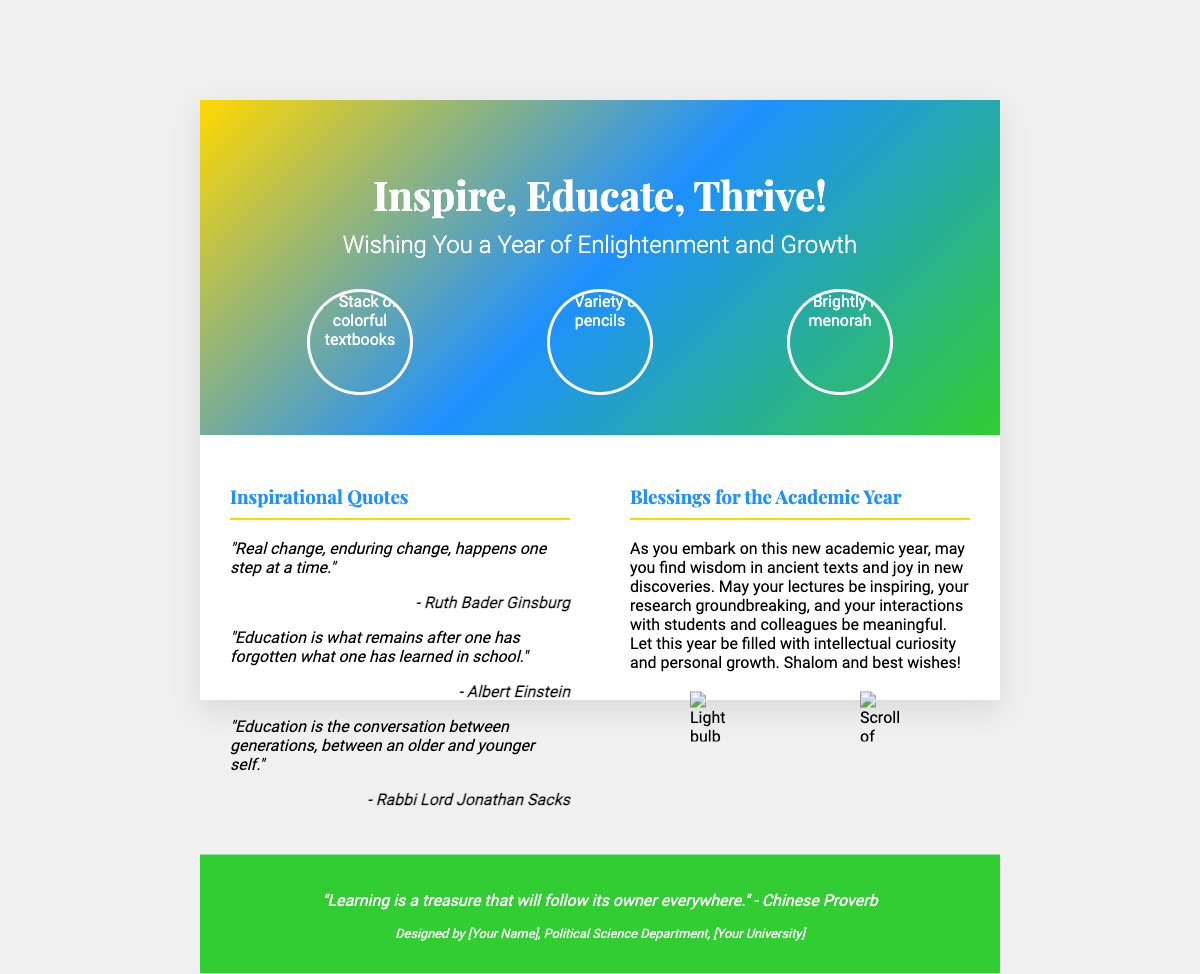What is the main title on the front cover? The main title on the front cover is the central message of the card, which reads "Inspire, Educate, Thrive!"
Answer: Inspire, Educate, Thrive! How many inspirational quotes are there in the document? The document includes three quotes under the section "Inspirational Quotes."
Answer: 3 Who is one of the authors of the quotes? One of the authors mentioned in the quotes is a prominent legal figure known for her work in gender equality.
Answer: Ruth Bader Ginsburg What is depicted next to the quote by Rabbi Lord Jonathan Sacks? The quote is located in the left section of the card, indicating the presence of authors and thought leaders in the field of education.
Answer: A quote by Rabbi Lord Jonathan Sacks What colors are used in the front cover's gradient background? The front cover features a vibrant gradient that includes shades of gold, blue, and green.
Answer: Gold, blue, green What does the back cover quote convey? The back cover quote implies that knowledge gained through learning is invaluable and accessible in all areas of life.
Answer: Learning is a treasure What symbolic imagery accompanies the blessings for the academic year? The imagery represents ideas and heritage, creating a strong connection to both creativity and tradition.
Answer: Light bulb and Torah scroll What is the primary theme of the card? The overarching theme of the card centers around motivation, learning, and academic growth for the upcoming year.
Answer: Enlightenment and growth What message does the card extend as students begin a new academic year? The message emphasizes the significance of wisdom and joy as students progress through their studies.
Answer: Wisdom in ancient texts and joy in new discoveries 